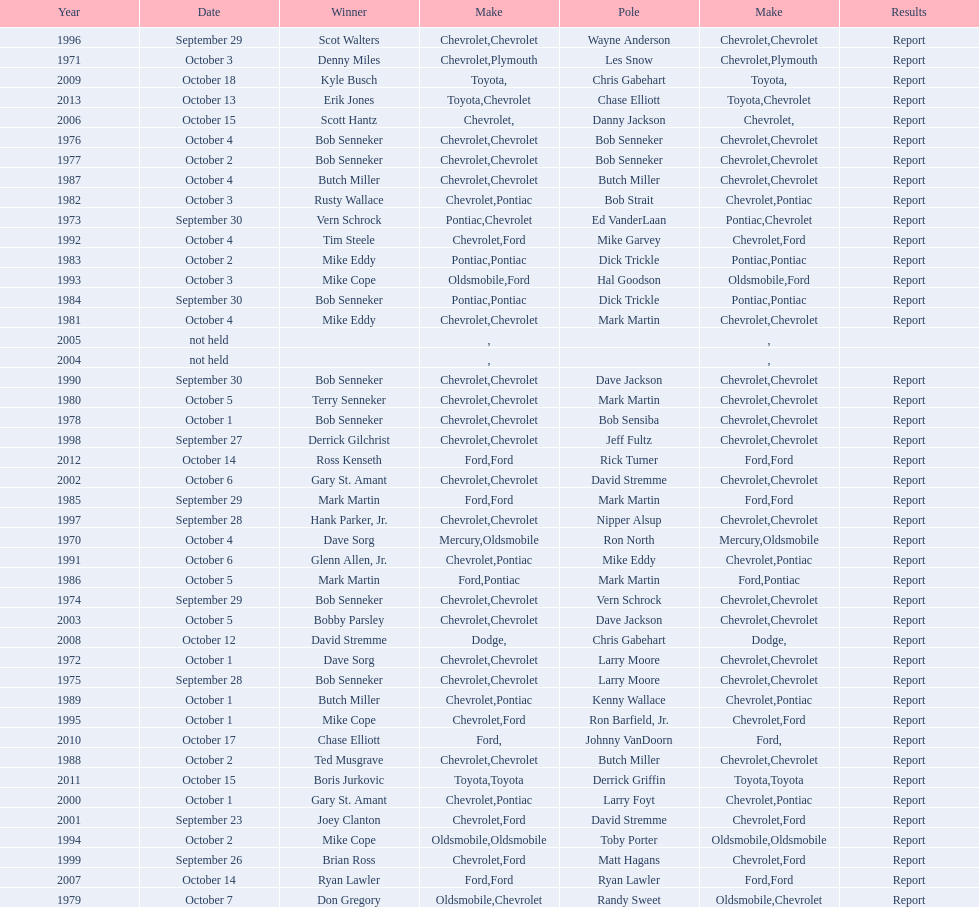Who on the list has the highest number of consecutive wins? Bob Senneker. 